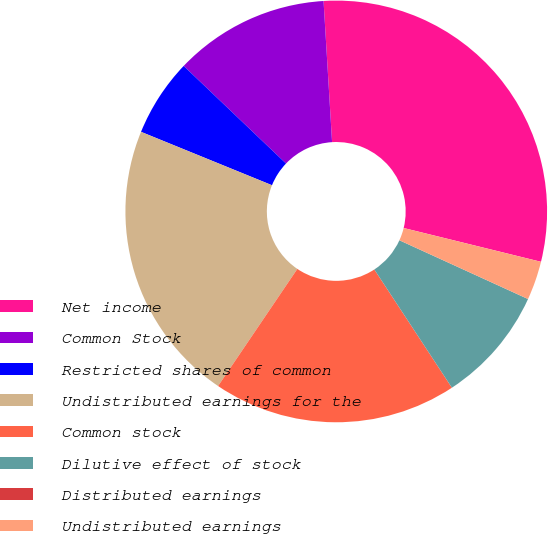<chart> <loc_0><loc_0><loc_500><loc_500><pie_chart><fcel>Net income<fcel>Common Stock<fcel>Restricted shares of common<fcel>Undistributed earnings for the<fcel>Common stock<fcel>Dilutive effect of stock<fcel>Distributed earnings<fcel>Undistributed earnings<nl><fcel>29.8%<fcel>11.92%<fcel>5.96%<fcel>21.69%<fcel>18.71%<fcel>8.94%<fcel>0.0%<fcel>2.98%<nl></chart> 